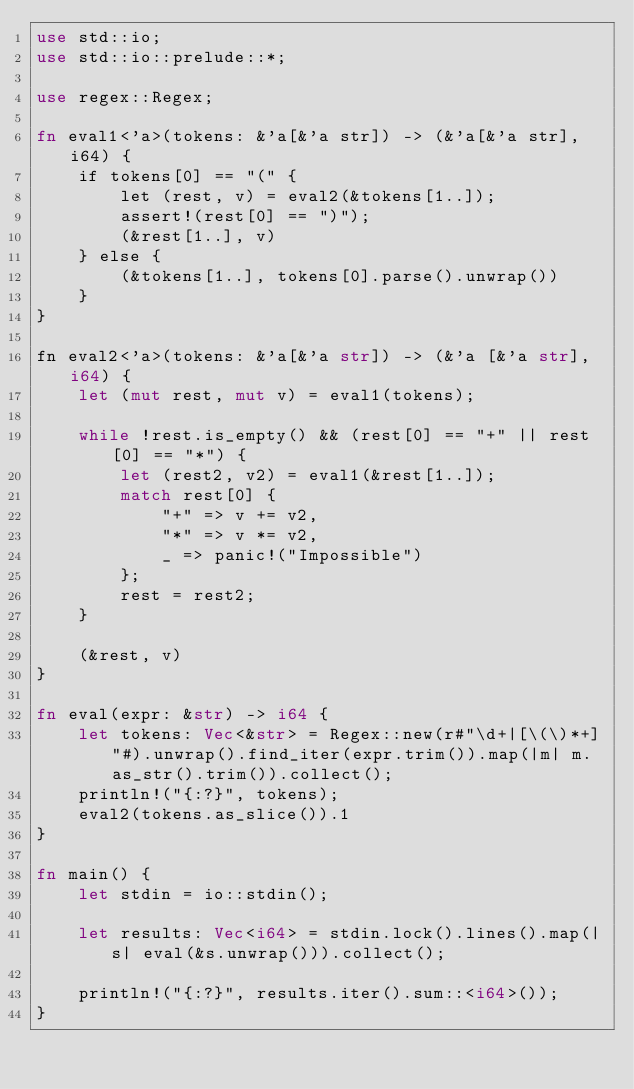<code> <loc_0><loc_0><loc_500><loc_500><_Rust_>use std::io;
use std::io::prelude::*;

use regex::Regex;

fn eval1<'a>(tokens: &'a[&'a str]) -> (&'a[&'a str], i64) {
    if tokens[0] == "(" {
        let (rest, v) = eval2(&tokens[1..]);
        assert!(rest[0] == ")");
        (&rest[1..], v)
    } else {
        (&tokens[1..], tokens[0].parse().unwrap())
    }
}

fn eval2<'a>(tokens: &'a[&'a str]) -> (&'a [&'a str], i64) {
    let (mut rest, mut v) = eval1(tokens);

    while !rest.is_empty() && (rest[0] == "+" || rest[0] == "*") {
        let (rest2, v2) = eval1(&rest[1..]);
        match rest[0] {
            "+" => v += v2,
            "*" => v *= v2,
            _ => panic!("Impossible")
        };
        rest = rest2;
    }

    (&rest, v)
}

fn eval(expr: &str) -> i64 {
    let tokens: Vec<&str> = Regex::new(r#"\d+|[\(\)*+]"#).unwrap().find_iter(expr.trim()).map(|m| m.as_str().trim()).collect();
    println!("{:?}", tokens);
    eval2(tokens.as_slice()).1
}

fn main() {
    let stdin = io::stdin();

    let results: Vec<i64> = stdin.lock().lines().map(|s| eval(&s.unwrap())).collect();

    println!("{:?}", results.iter().sum::<i64>());
}
</code> 